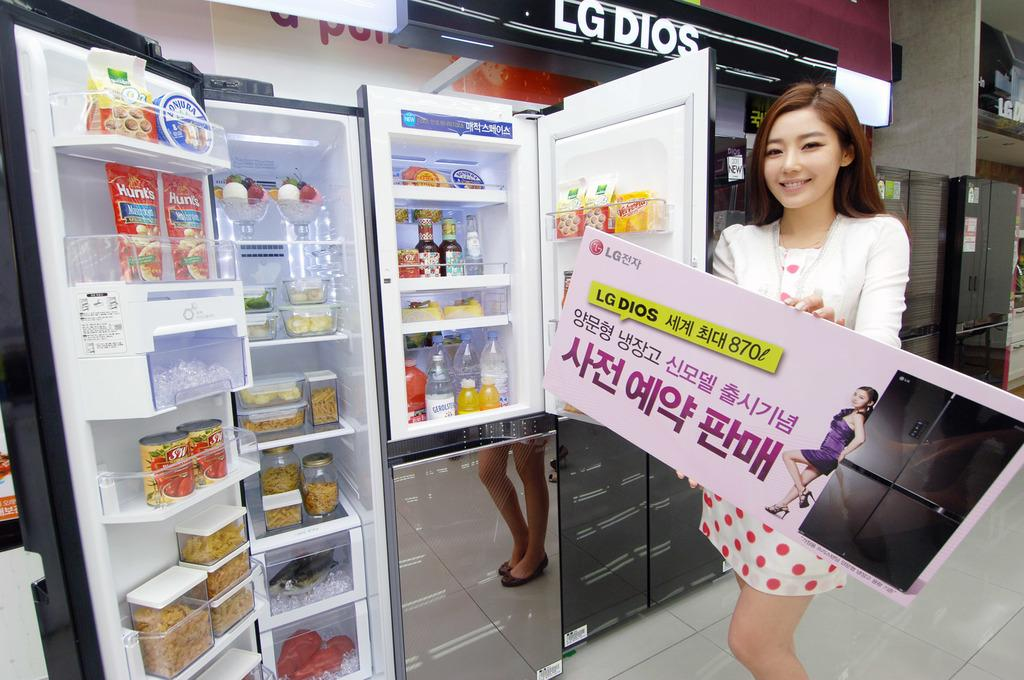<image>
Relay a brief, clear account of the picture shown. a woman holding an add infront of a fridge for LG 